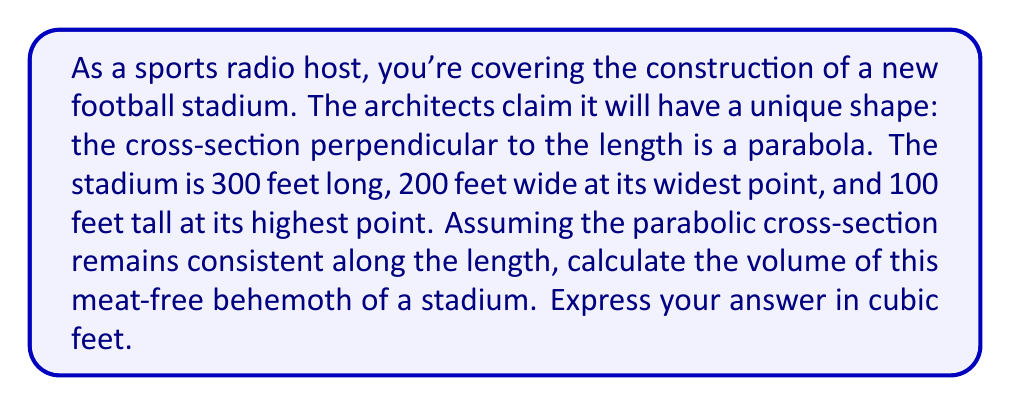Provide a solution to this math problem. Let's approach this step-by-step:

1) The cross-section of the stadium is a parabola. We need to set up an equation for this parabola.

2) The parabola has a width of 200 feet and a height of 100 feet. We can describe this with the equation:

   $$y = -\frac{4h}{w^2}x^2 + h$$

   where $h = 100$ and $w = 100$ (half the width).

3) Substituting these values:

   $$y = -\frac{4(100)}{100^2}x^2 + 100 = -0.04x^2 + 100$$

4) To find the volume, we need to integrate the area of this cross-section over the length of the stadium. The area of the cross-section at any point is given by:

   $$A(x) = 2\int_0^{100} (-0.04x^2 + 100) dx$$

5) Evaluating this integral:

   $$A(x) = 2[-\frac{0.04x^3}{3} + 100x]_0^{100} = 2[(-133.33 + 10000) - 0] = 19733.33$$

6) Now, we need to integrate this area over the length of the stadium (300 feet):

   $$V = \int_0^{300} 19733.33 dx = 19733.33x|_0^{300} = 5,920,000$$

Therefore, the volume of the stadium is 5,920,000 cubic feet.
Answer: 5,920,000 cubic feet 